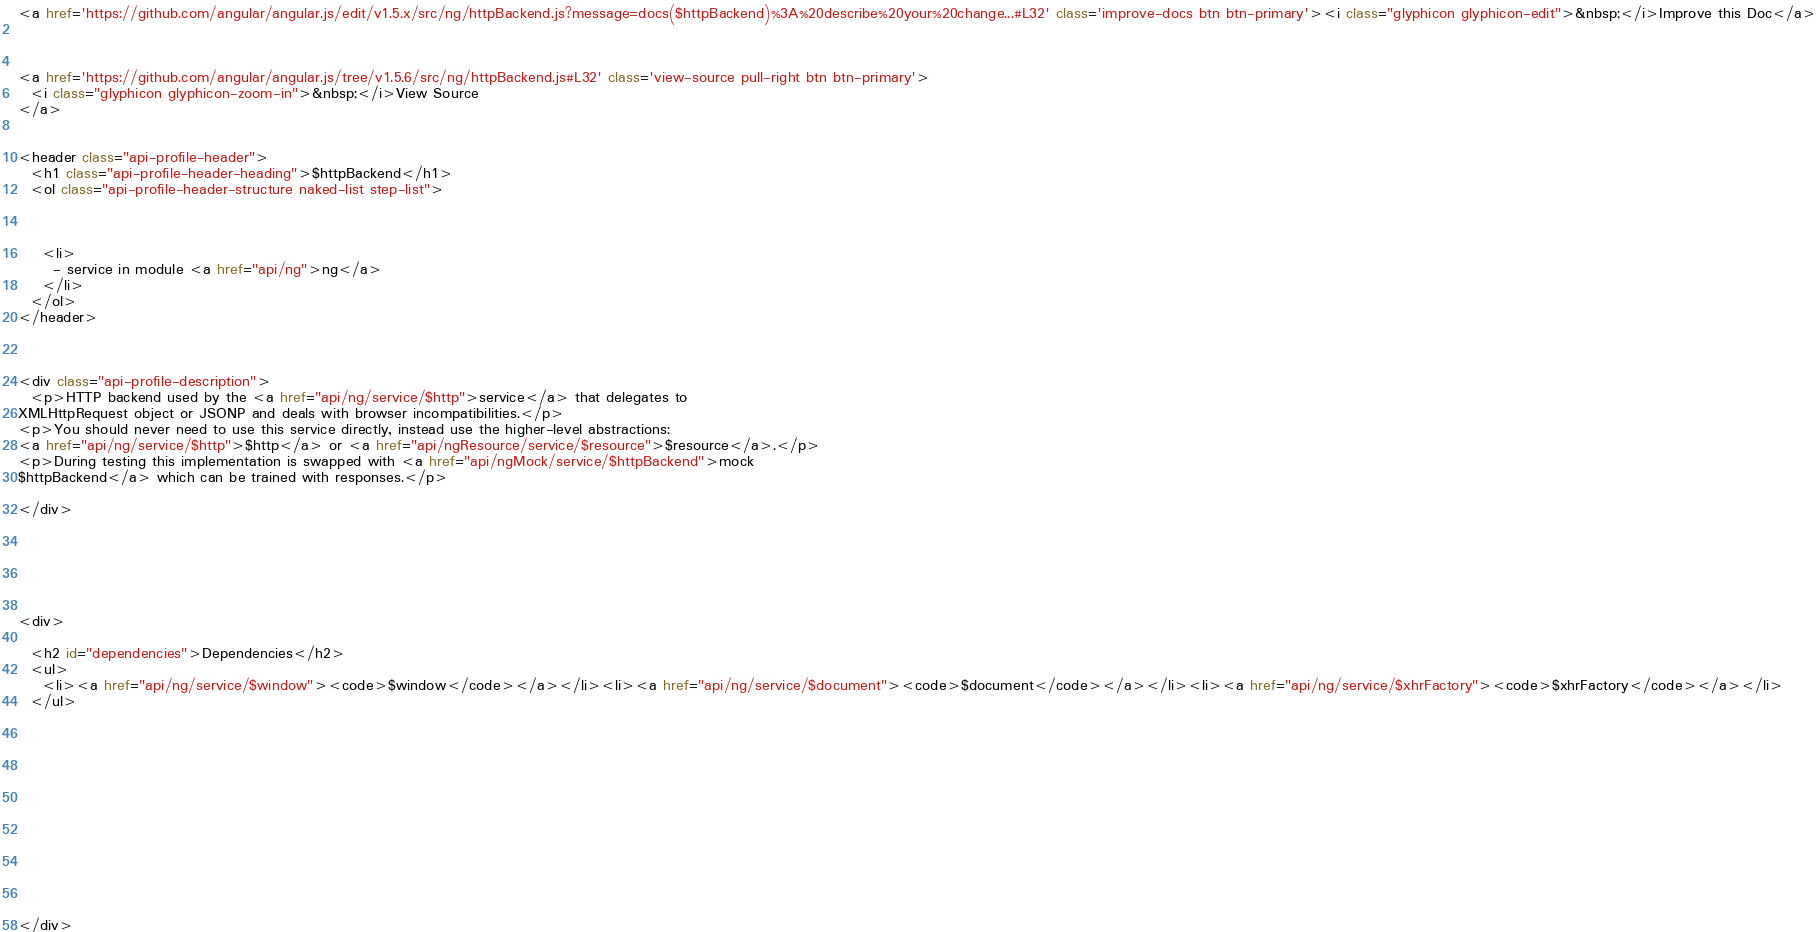<code> <loc_0><loc_0><loc_500><loc_500><_HTML_><a href='https://github.com/angular/angular.js/edit/v1.5.x/src/ng/httpBackend.js?message=docs($httpBackend)%3A%20describe%20your%20change...#L32' class='improve-docs btn btn-primary'><i class="glyphicon glyphicon-edit">&nbsp;</i>Improve this Doc</a>



<a href='https://github.com/angular/angular.js/tree/v1.5.6/src/ng/httpBackend.js#L32' class='view-source pull-right btn btn-primary'>
  <i class="glyphicon glyphicon-zoom-in">&nbsp;</i>View Source
</a>


<header class="api-profile-header">
  <h1 class="api-profile-header-heading">$httpBackend</h1>
  <ol class="api-profile-header-structure naked-list step-list">
    
  

    <li>
      - service in module <a href="api/ng">ng</a>
    </li>
  </ol>
</header>



<div class="api-profile-description">
  <p>HTTP backend used by the <a href="api/ng/service/$http">service</a> that delegates to
XMLHttpRequest object or JSONP and deals with browser incompatibilities.</p>
<p>You should never need to use this service directly, instead use the higher-level abstractions:
<a href="api/ng/service/$http">$http</a> or <a href="api/ngResource/service/$resource">$resource</a>.</p>
<p>During testing this implementation is swapped with <a href="api/ngMock/service/$httpBackend">mock
$httpBackend</a> which can be trained with responses.</p>

</div>






<div>
  
  <h2 id="dependencies">Dependencies</h2>
  <ul>
    <li><a href="api/ng/service/$window"><code>$window</code></a></li><li><a href="api/ng/service/$document"><code>$document</code></a></li><li><a href="api/ng/service/$xhrFactory"><code>$xhrFactory</code></a></li>
  </ul>
  

    

  

  
  
  



  
</div>


</code> 